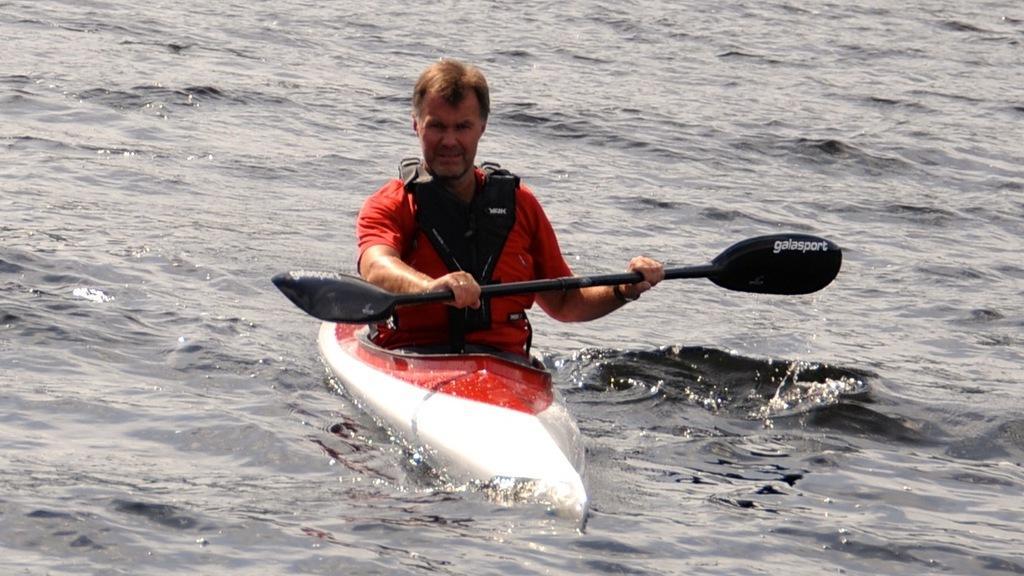Describe this image in one or two sentences. In this picture I can see a man holding a paddle and sitting on the boat, which is on the water. 